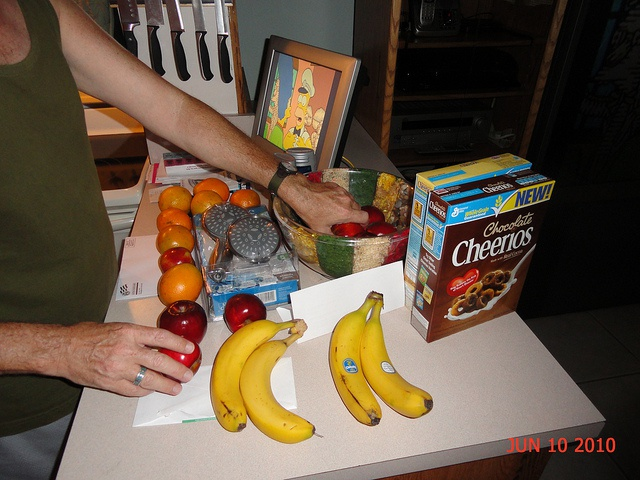Describe the objects in this image and their specific colors. I can see people in maroon, black, gray, and tan tones, dining table in maroon, darkgray, lightgray, and gray tones, bowl in maroon, gray, black, and olive tones, banana in maroon, orange, olive, and gold tones, and banana in maroon, orange, lightgray, and tan tones in this image. 